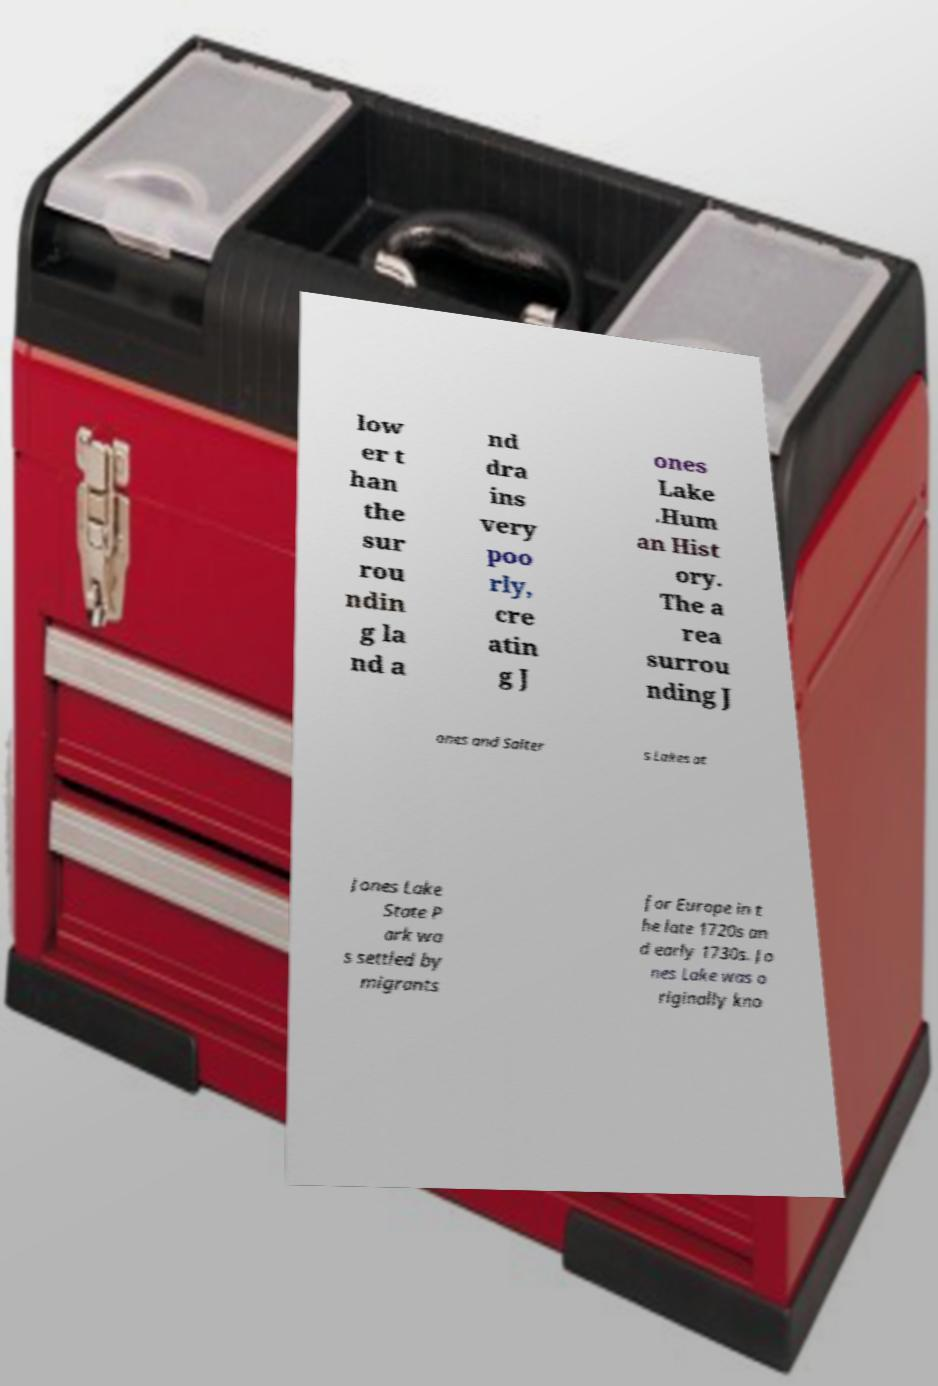For documentation purposes, I need the text within this image transcribed. Could you provide that? low er t han the sur rou ndin g la nd a nd dra ins very poo rly, cre atin g J ones Lake .Hum an Hist ory. The a rea surrou nding J ones and Salter s Lakes at Jones Lake State P ark wa s settled by migrants for Europe in t he late 1720s an d early 1730s. Jo nes Lake was o riginally kno 